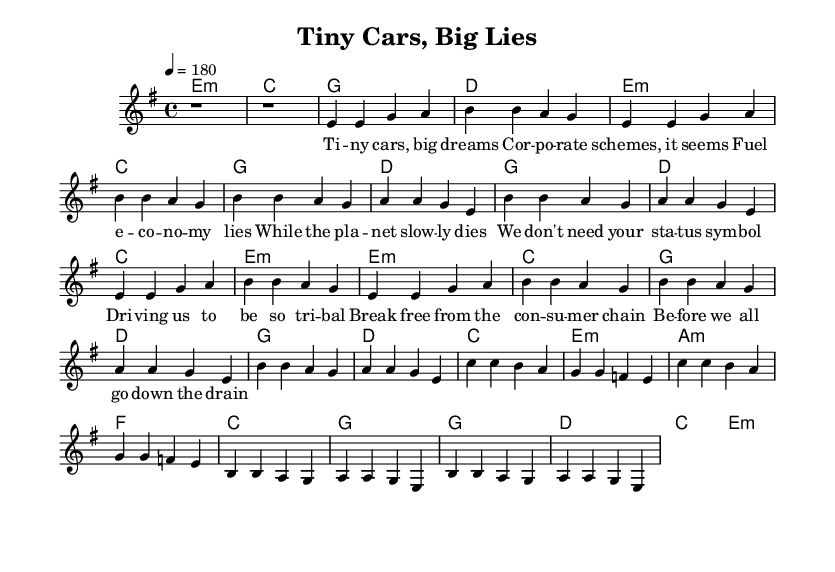What is the key signature of this music? The key signature is E minor, which is indicated by the presence of one sharp (F#) in the key signature box.
Answer: E minor What is the time signature of this music? The time signature is 4/4, shown at the beginning of the score, meaning there are four beats in each measure and the quarter note gets one beat.
Answer: 4/4 What is the tempo marking of this piece? The tempo marking indicates a speed of 180 BPM (beats per minute), as shown at the start of the score. This suggests a fast pace typical of punk music.
Answer: 180 How many verses are there in the song? The song contains two verses, identifiable by the repeated lyrical structure, and they are separated by the chorus.
Answer: 2 What is the chord progression used in the chorus? The chorus follows the chord progression G, D, C, E minor as indicated in the harmonies section, which repeats throughout the chorus sections.
Answer: G, D, C, E minor What themes are critiqued in the lyrics? The lyrics critique consumerism, corporate culture, and environmental issues, as indicated by phrases referring to “corporate schemes” and “the planet slowly dies.”
Answer: Consumerism and corporate culture What is the purpose of the bridge in punk songs like this one? The bridge serves to introduce a contrast to the verses and chorus, often heightening emotional intensity or shifting the theme. In this piece, it shifts to A minor, enhancing the rebellious tone.
Answer: Contrast and emotional intensity 